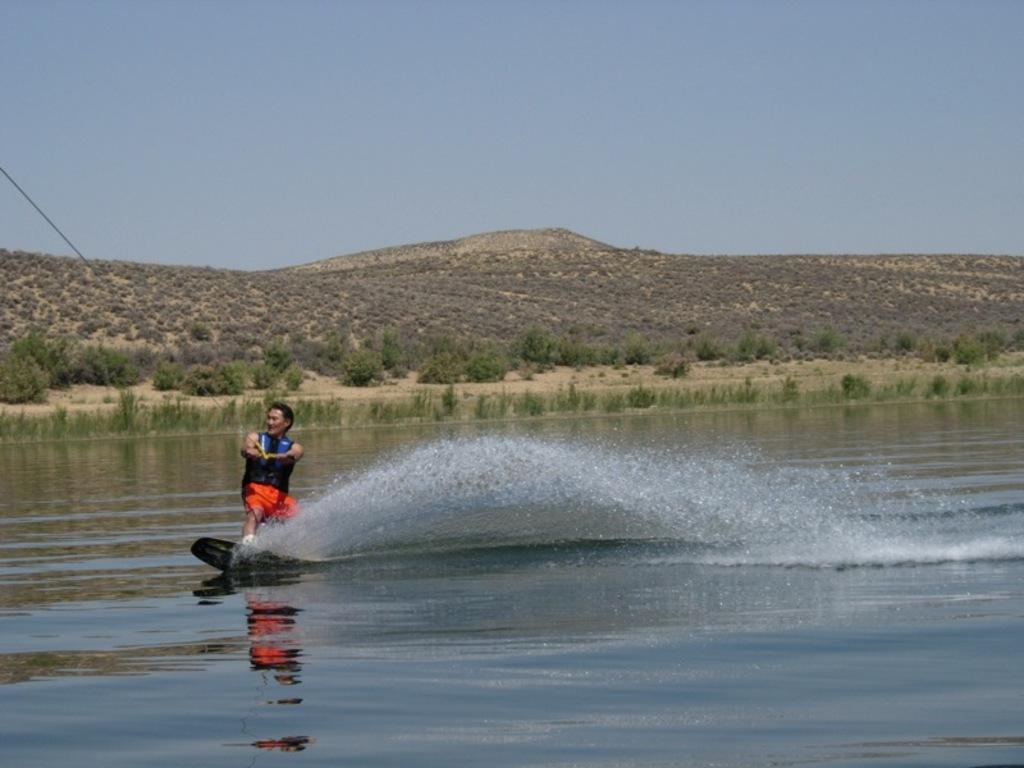What activity is the person in the image engaged in? The person is surfing in the water. What is the person holding while surfing? The person is holding a rope while surfing. What can be seen in the background of the image? There are hills in the background of the image, with small plants present on them. What is visible at the top of the image? The sky is visible at the top of the image. What type of liquid can be seen flowing from the army in the image? There is no army or liquid present in the image; it features a person surfing in the water with hills and plants in the background. 